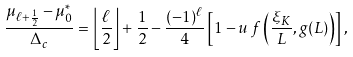Convert formula to latex. <formula><loc_0><loc_0><loc_500><loc_500>\frac { \mu _ { \ell + \frac { 1 } { 2 } } - \mu _ { 0 } ^ { * } } { \Delta _ { c } } = \left \lfloor \frac { \ell } { 2 } \right \rfloor + \frac { 1 } { 2 } - \frac { ( - 1 ) ^ { \ell } } { 4 } \left [ 1 - u \, f \left ( \frac { \xi _ { K } } { L } , g ( L ) \right ) \right ] ,</formula> 